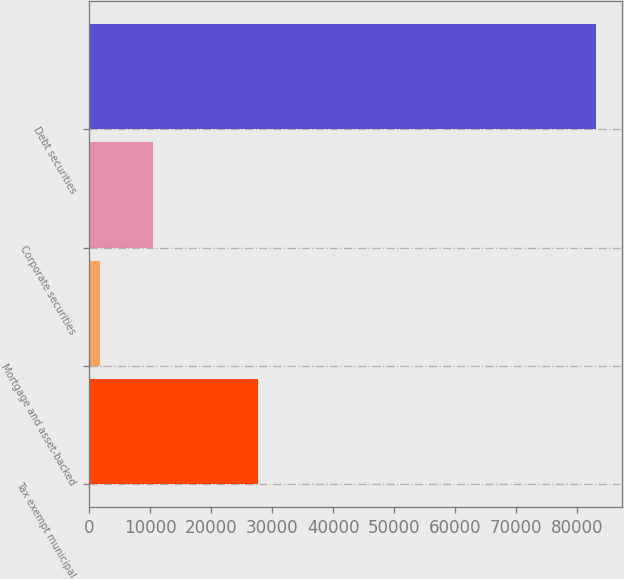Convert chart to OTSL. <chart><loc_0><loc_0><loc_500><loc_500><bar_chart><fcel>Tax exempt municipal<fcel>Mortgage and asset-backed<fcel>Corporate securities<fcel>Debt securities<nl><fcel>27649<fcel>1841<fcel>10532<fcel>83156<nl></chart> 